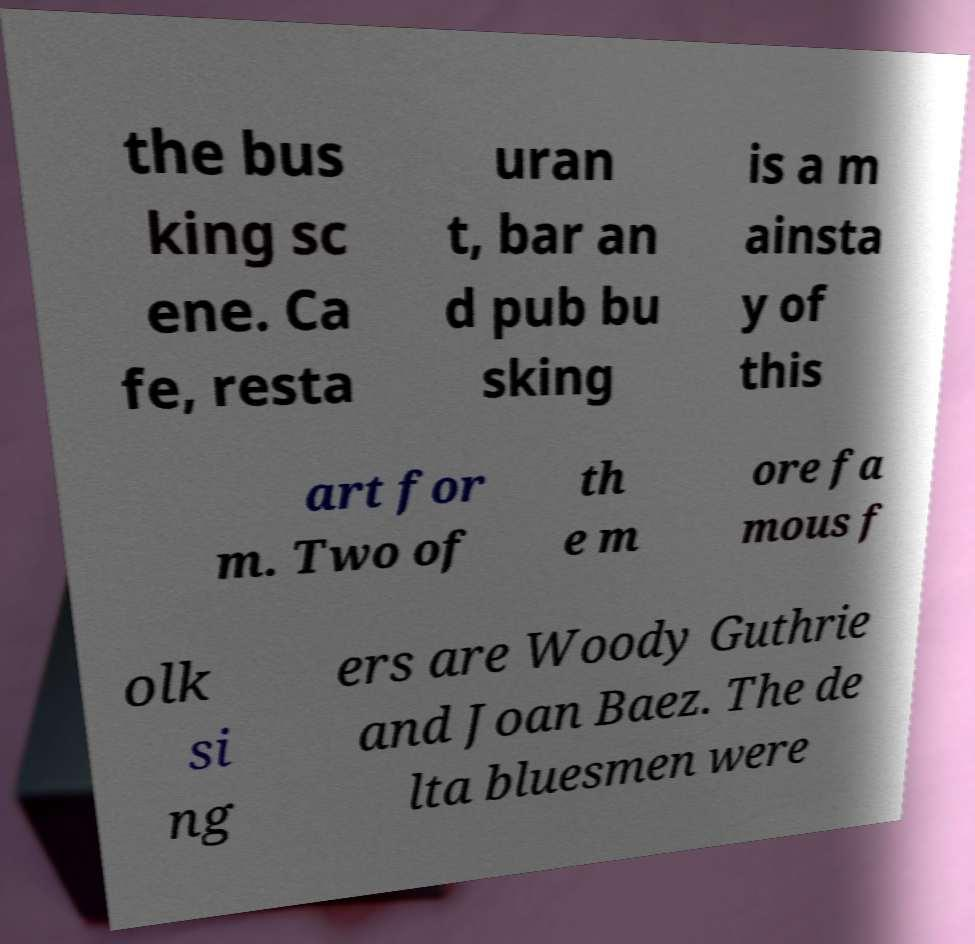Please identify and transcribe the text found in this image. the bus king sc ene. Ca fe, resta uran t, bar an d pub bu sking is a m ainsta y of this art for m. Two of th e m ore fa mous f olk si ng ers are Woody Guthrie and Joan Baez. The de lta bluesmen were 